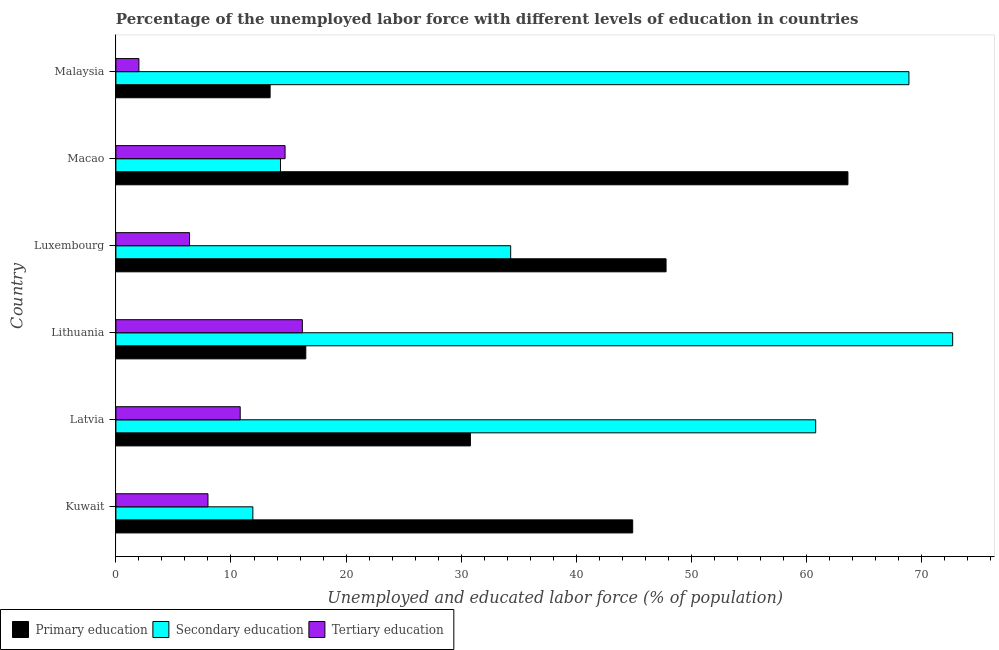How many different coloured bars are there?
Offer a terse response. 3. How many groups of bars are there?
Keep it short and to the point. 6. Are the number of bars per tick equal to the number of legend labels?
Ensure brevity in your answer.  Yes. How many bars are there on the 1st tick from the top?
Provide a succinct answer. 3. How many bars are there on the 4th tick from the bottom?
Your response must be concise. 3. What is the label of the 5th group of bars from the top?
Offer a very short reply. Latvia. What is the percentage of labor force who received primary education in Luxembourg?
Keep it short and to the point. 47.8. Across all countries, what is the maximum percentage of labor force who received primary education?
Your response must be concise. 63.6. Across all countries, what is the minimum percentage of labor force who received tertiary education?
Provide a short and direct response. 2. In which country was the percentage of labor force who received tertiary education maximum?
Keep it short and to the point. Lithuania. In which country was the percentage of labor force who received primary education minimum?
Offer a terse response. Malaysia. What is the total percentage of labor force who received tertiary education in the graph?
Provide a short and direct response. 58.1. What is the difference between the percentage of labor force who received tertiary education in Luxembourg and the percentage of labor force who received secondary education in Kuwait?
Provide a succinct answer. -5.5. What is the average percentage of labor force who received primary education per country?
Provide a succinct answer. 36.17. What is the difference between the percentage of labor force who received secondary education and percentage of labor force who received tertiary education in Malaysia?
Ensure brevity in your answer.  66.9. What is the ratio of the percentage of labor force who received primary education in Luxembourg to that in Malaysia?
Keep it short and to the point. 3.57. What is the difference between the highest and the second highest percentage of labor force who received tertiary education?
Offer a very short reply. 1.5. What is the difference between the highest and the lowest percentage of labor force who received secondary education?
Offer a very short reply. 60.8. In how many countries, is the percentage of labor force who received secondary education greater than the average percentage of labor force who received secondary education taken over all countries?
Provide a short and direct response. 3. What does the 1st bar from the top in Kuwait represents?
Provide a short and direct response. Tertiary education. What does the 2nd bar from the bottom in Macao represents?
Keep it short and to the point. Secondary education. Is it the case that in every country, the sum of the percentage of labor force who received primary education and percentage of labor force who received secondary education is greater than the percentage of labor force who received tertiary education?
Keep it short and to the point. Yes. How many bars are there?
Provide a short and direct response. 18. Are the values on the major ticks of X-axis written in scientific E-notation?
Your answer should be very brief. No. Does the graph contain any zero values?
Offer a terse response. No. Does the graph contain grids?
Keep it short and to the point. No. What is the title of the graph?
Your answer should be compact. Percentage of the unemployed labor force with different levels of education in countries. What is the label or title of the X-axis?
Offer a very short reply. Unemployed and educated labor force (% of population). What is the label or title of the Y-axis?
Offer a very short reply. Country. What is the Unemployed and educated labor force (% of population) in Primary education in Kuwait?
Your response must be concise. 44.9. What is the Unemployed and educated labor force (% of population) in Secondary education in Kuwait?
Provide a succinct answer. 11.9. What is the Unemployed and educated labor force (% of population) of Tertiary education in Kuwait?
Provide a short and direct response. 8. What is the Unemployed and educated labor force (% of population) in Primary education in Latvia?
Offer a terse response. 30.8. What is the Unemployed and educated labor force (% of population) of Secondary education in Latvia?
Offer a terse response. 60.8. What is the Unemployed and educated labor force (% of population) of Tertiary education in Latvia?
Give a very brief answer. 10.8. What is the Unemployed and educated labor force (% of population) of Primary education in Lithuania?
Keep it short and to the point. 16.5. What is the Unemployed and educated labor force (% of population) of Secondary education in Lithuania?
Make the answer very short. 72.7. What is the Unemployed and educated labor force (% of population) of Tertiary education in Lithuania?
Your answer should be very brief. 16.2. What is the Unemployed and educated labor force (% of population) in Primary education in Luxembourg?
Provide a succinct answer. 47.8. What is the Unemployed and educated labor force (% of population) in Secondary education in Luxembourg?
Provide a short and direct response. 34.3. What is the Unemployed and educated labor force (% of population) in Tertiary education in Luxembourg?
Your response must be concise. 6.4. What is the Unemployed and educated labor force (% of population) of Primary education in Macao?
Make the answer very short. 63.6. What is the Unemployed and educated labor force (% of population) in Secondary education in Macao?
Provide a short and direct response. 14.3. What is the Unemployed and educated labor force (% of population) of Tertiary education in Macao?
Ensure brevity in your answer.  14.7. What is the Unemployed and educated labor force (% of population) in Primary education in Malaysia?
Offer a very short reply. 13.4. What is the Unemployed and educated labor force (% of population) of Secondary education in Malaysia?
Offer a terse response. 68.9. What is the Unemployed and educated labor force (% of population) in Tertiary education in Malaysia?
Give a very brief answer. 2. Across all countries, what is the maximum Unemployed and educated labor force (% of population) of Primary education?
Keep it short and to the point. 63.6. Across all countries, what is the maximum Unemployed and educated labor force (% of population) in Secondary education?
Make the answer very short. 72.7. Across all countries, what is the maximum Unemployed and educated labor force (% of population) in Tertiary education?
Ensure brevity in your answer.  16.2. Across all countries, what is the minimum Unemployed and educated labor force (% of population) in Primary education?
Offer a terse response. 13.4. Across all countries, what is the minimum Unemployed and educated labor force (% of population) in Secondary education?
Provide a short and direct response. 11.9. Across all countries, what is the minimum Unemployed and educated labor force (% of population) in Tertiary education?
Your response must be concise. 2. What is the total Unemployed and educated labor force (% of population) in Primary education in the graph?
Your answer should be very brief. 217. What is the total Unemployed and educated labor force (% of population) of Secondary education in the graph?
Give a very brief answer. 262.9. What is the total Unemployed and educated labor force (% of population) in Tertiary education in the graph?
Your answer should be very brief. 58.1. What is the difference between the Unemployed and educated labor force (% of population) in Secondary education in Kuwait and that in Latvia?
Make the answer very short. -48.9. What is the difference between the Unemployed and educated labor force (% of population) of Primary education in Kuwait and that in Lithuania?
Give a very brief answer. 28.4. What is the difference between the Unemployed and educated labor force (% of population) of Secondary education in Kuwait and that in Lithuania?
Provide a succinct answer. -60.8. What is the difference between the Unemployed and educated labor force (% of population) in Primary education in Kuwait and that in Luxembourg?
Ensure brevity in your answer.  -2.9. What is the difference between the Unemployed and educated labor force (% of population) in Secondary education in Kuwait and that in Luxembourg?
Keep it short and to the point. -22.4. What is the difference between the Unemployed and educated labor force (% of population) of Tertiary education in Kuwait and that in Luxembourg?
Ensure brevity in your answer.  1.6. What is the difference between the Unemployed and educated labor force (% of population) in Primary education in Kuwait and that in Macao?
Your response must be concise. -18.7. What is the difference between the Unemployed and educated labor force (% of population) in Secondary education in Kuwait and that in Macao?
Offer a terse response. -2.4. What is the difference between the Unemployed and educated labor force (% of population) in Primary education in Kuwait and that in Malaysia?
Offer a very short reply. 31.5. What is the difference between the Unemployed and educated labor force (% of population) in Secondary education in Kuwait and that in Malaysia?
Keep it short and to the point. -57. What is the difference between the Unemployed and educated labor force (% of population) of Primary education in Latvia and that in Lithuania?
Ensure brevity in your answer.  14.3. What is the difference between the Unemployed and educated labor force (% of population) of Secondary education in Latvia and that in Lithuania?
Give a very brief answer. -11.9. What is the difference between the Unemployed and educated labor force (% of population) of Primary education in Latvia and that in Luxembourg?
Provide a succinct answer. -17. What is the difference between the Unemployed and educated labor force (% of population) in Secondary education in Latvia and that in Luxembourg?
Offer a very short reply. 26.5. What is the difference between the Unemployed and educated labor force (% of population) of Tertiary education in Latvia and that in Luxembourg?
Offer a very short reply. 4.4. What is the difference between the Unemployed and educated labor force (% of population) in Primary education in Latvia and that in Macao?
Offer a very short reply. -32.8. What is the difference between the Unemployed and educated labor force (% of population) in Secondary education in Latvia and that in Macao?
Give a very brief answer. 46.5. What is the difference between the Unemployed and educated labor force (% of population) of Tertiary education in Latvia and that in Macao?
Your response must be concise. -3.9. What is the difference between the Unemployed and educated labor force (% of population) in Primary education in Latvia and that in Malaysia?
Make the answer very short. 17.4. What is the difference between the Unemployed and educated labor force (% of population) of Primary education in Lithuania and that in Luxembourg?
Make the answer very short. -31.3. What is the difference between the Unemployed and educated labor force (% of population) of Secondary education in Lithuania and that in Luxembourg?
Provide a short and direct response. 38.4. What is the difference between the Unemployed and educated labor force (% of population) in Tertiary education in Lithuania and that in Luxembourg?
Offer a very short reply. 9.8. What is the difference between the Unemployed and educated labor force (% of population) of Primary education in Lithuania and that in Macao?
Offer a terse response. -47.1. What is the difference between the Unemployed and educated labor force (% of population) of Secondary education in Lithuania and that in Macao?
Provide a short and direct response. 58.4. What is the difference between the Unemployed and educated labor force (% of population) in Tertiary education in Lithuania and that in Macao?
Offer a terse response. 1.5. What is the difference between the Unemployed and educated labor force (% of population) of Primary education in Luxembourg and that in Macao?
Your answer should be compact. -15.8. What is the difference between the Unemployed and educated labor force (% of population) in Secondary education in Luxembourg and that in Macao?
Your answer should be very brief. 20. What is the difference between the Unemployed and educated labor force (% of population) of Primary education in Luxembourg and that in Malaysia?
Provide a succinct answer. 34.4. What is the difference between the Unemployed and educated labor force (% of population) of Secondary education in Luxembourg and that in Malaysia?
Provide a short and direct response. -34.6. What is the difference between the Unemployed and educated labor force (% of population) of Primary education in Macao and that in Malaysia?
Give a very brief answer. 50.2. What is the difference between the Unemployed and educated labor force (% of population) in Secondary education in Macao and that in Malaysia?
Your response must be concise. -54.6. What is the difference between the Unemployed and educated labor force (% of population) in Primary education in Kuwait and the Unemployed and educated labor force (% of population) in Secondary education in Latvia?
Your answer should be very brief. -15.9. What is the difference between the Unemployed and educated labor force (% of population) of Primary education in Kuwait and the Unemployed and educated labor force (% of population) of Tertiary education in Latvia?
Your response must be concise. 34.1. What is the difference between the Unemployed and educated labor force (% of population) of Secondary education in Kuwait and the Unemployed and educated labor force (% of population) of Tertiary education in Latvia?
Provide a succinct answer. 1.1. What is the difference between the Unemployed and educated labor force (% of population) in Primary education in Kuwait and the Unemployed and educated labor force (% of population) in Secondary education in Lithuania?
Your answer should be very brief. -27.8. What is the difference between the Unemployed and educated labor force (% of population) in Primary education in Kuwait and the Unemployed and educated labor force (% of population) in Tertiary education in Lithuania?
Offer a very short reply. 28.7. What is the difference between the Unemployed and educated labor force (% of population) of Primary education in Kuwait and the Unemployed and educated labor force (% of population) of Secondary education in Luxembourg?
Give a very brief answer. 10.6. What is the difference between the Unemployed and educated labor force (% of population) of Primary education in Kuwait and the Unemployed and educated labor force (% of population) of Tertiary education in Luxembourg?
Ensure brevity in your answer.  38.5. What is the difference between the Unemployed and educated labor force (% of population) of Secondary education in Kuwait and the Unemployed and educated labor force (% of population) of Tertiary education in Luxembourg?
Your answer should be very brief. 5.5. What is the difference between the Unemployed and educated labor force (% of population) of Primary education in Kuwait and the Unemployed and educated labor force (% of population) of Secondary education in Macao?
Offer a very short reply. 30.6. What is the difference between the Unemployed and educated labor force (% of population) in Primary education in Kuwait and the Unemployed and educated labor force (% of population) in Tertiary education in Macao?
Your answer should be compact. 30.2. What is the difference between the Unemployed and educated labor force (% of population) of Primary education in Kuwait and the Unemployed and educated labor force (% of population) of Secondary education in Malaysia?
Your answer should be compact. -24. What is the difference between the Unemployed and educated labor force (% of population) in Primary education in Kuwait and the Unemployed and educated labor force (% of population) in Tertiary education in Malaysia?
Your response must be concise. 42.9. What is the difference between the Unemployed and educated labor force (% of population) in Secondary education in Kuwait and the Unemployed and educated labor force (% of population) in Tertiary education in Malaysia?
Provide a short and direct response. 9.9. What is the difference between the Unemployed and educated labor force (% of population) in Primary education in Latvia and the Unemployed and educated labor force (% of population) in Secondary education in Lithuania?
Provide a succinct answer. -41.9. What is the difference between the Unemployed and educated labor force (% of population) of Primary education in Latvia and the Unemployed and educated labor force (% of population) of Tertiary education in Lithuania?
Make the answer very short. 14.6. What is the difference between the Unemployed and educated labor force (% of population) of Secondary education in Latvia and the Unemployed and educated labor force (% of population) of Tertiary education in Lithuania?
Offer a very short reply. 44.6. What is the difference between the Unemployed and educated labor force (% of population) in Primary education in Latvia and the Unemployed and educated labor force (% of population) in Tertiary education in Luxembourg?
Ensure brevity in your answer.  24.4. What is the difference between the Unemployed and educated labor force (% of population) of Secondary education in Latvia and the Unemployed and educated labor force (% of population) of Tertiary education in Luxembourg?
Offer a very short reply. 54.4. What is the difference between the Unemployed and educated labor force (% of population) in Primary education in Latvia and the Unemployed and educated labor force (% of population) in Secondary education in Macao?
Ensure brevity in your answer.  16.5. What is the difference between the Unemployed and educated labor force (% of population) of Primary education in Latvia and the Unemployed and educated labor force (% of population) of Tertiary education in Macao?
Provide a succinct answer. 16.1. What is the difference between the Unemployed and educated labor force (% of population) in Secondary education in Latvia and the Unemployed and educated labor force (% of population) in Tertiary education in Macao?
Offer a terse response. 46.1. What is the difference between the Unemployed and educated labor force (% of population) in Primary education in Latvia and the Unemployed and educated labor force (% of population) in Secondary education in Malaysia?
Give a very brief answer. -38.1. What is the difference between the Unemployed and educated labor force (% of population) of Primary education in Latvia and the Unemployed and educated labor force (% of population) of Tertiary education in Malaysia?
Your answer should be compact. 28.8. What is the difference between the Unemployed and educated labor force (% of population) of Secondary education in Latvia and the Unemployed and educated labor force (% of population) of Tertiary education in Malaysia?
Give a very brief answer. 58.8. What is the difference between the Unemployed and educated labor force (% of population) in Primary education in Lithuania and the Unemployed and educated labor force (% of population) in Secondary education in Luxembourg?
Give a very brief answer. -17.8. What is the difference between the Unemployed and educated labor force (% of population) of Primary education in Lithuania and the Unemployed and educated labor force (% of population) of Tertiary education in Luxembourg?
Keep it short and to the point. 10.1. What is the difference between the Unemployed and educated labor force (% of population) of Secondary education in Lithuania and the Unemployed and educated labor force (% of population) of Tertiary education in Luxembourg?
Your answer should be compact. 66.3. What is the difference between the Unemployed and educated labor force (% of population) in Primary education in Lithuania and the Unemployed and educated labor force (% of population) in Secondary education in Malaysia?
Your answer should be compact. -52.4. What is the difference between the Unemployed and educated labor force (% of population) in Secondary education in Lithuania and the Unemployed and educated labor force (% of population) in Tertiary education in Malaysia?
Provide a succinct answer. 70.7. What is the difference between the Unemployed and educated labor force (% of population) in Primary education in Luxembourg and the Unemployed and educated labor force (% of population) in Secondary education in Macao?
Keep it short and to the point. 33.5. What is the difference between the Unemployed and educated labor force (% of population) in Primary education in Luxembourg and the Unemployed and educated labor force (% of population) in Tertiary education in Macao?
Your response must be concise. 33.1. What is the difference between the Unemployed and educated labor force (% of population) of Secondary education in Luxembourg and the Unemployed and educated labor force (% of population) of Tertiary education in Macao?
Offer a terse response. 19.6. What is the difference between the Unemployed and educated labor force (% of population) of Primary education in Luxembourg and the Unemployed and educated labor force (% of population) of Secondary education in Malaysia?
Provide a succinct answer. -21.1. What is the difference between the Unemployed and educated labor force (% of population) of Primary education in Luxembourg and the Unemployed and educated labor force (% of population) of Tertiary education in Malaysia?
Provide a succinct answer. 45.8. What is the difference between the Unemployed and educated labor force (% of population) in Secondary education in Luxembourg and the Unemployed and educated labor force (% of population) in Tertiary education in Malaysia?
Ensure brevity in your answer.  32.3. What is the difference between the Unemployed and educated labor force (% of population) in Primary education in Macao and the Unemployed and educated labor force (% of population) in Tertiary education in Malaysia?
Offer a terse response. 61.6. What is the average Unemployed and educated labor force (% of population) of Primary education per country?
Provide a succinct answer. 36.17. What is the average Unemployed and educated labor force (% of population) of Secondary education per country?
Provide a short and direct response. 43.82. What is the average Unemployed and educated labor force (% of population) in Tertiary education per country?
Offer a terse response. 9.68. What is the difference between the Unemployed and educated labor force (% of population) of Primary education and Unemployed and educated labor force (% of population) of Tertiary education in Kuwait?
Provide a short and direct response. 36.9. What is the difference between the Unemployed and educated labor force (% of population) of Primary education and Unemployed and educated labor force (% of population) of Secondary education in Lithuania?
Your answer should be compact. -56.2. What is the difference between the Unemployed and educated labor force (% of population) of Primary education and Unemployed and educated labor force (% of population) of Tertiary education in Lithuania?
Your answer should be very brief. 0.3. What is the difference between the Unemployed and educated labor force (% of population) in Secondary education and Unemployed and educated labor force (% of population) in Tertiary education in Lithuania?
Provide a succinct answer. 56.5. What is the difference between the Unemployed and educated labor force (% of population) of Primary education and Unemployed and educated labor force (% of population) of Tertiary education in Luxembourg?
Offer a very short reply. 41.4. What is the difference between the Unemployed and educated labor force (% of population) of Secondary education and Unemployed and educated labor force (% of population) of Tertiary education in Luxembourg?
Make the answer very short. 27.9. What is the difference between the Unemployed and educated labor force (% of population) in Primary education and Unemployed and educated labor force (% of population) in Secondary education in Macao?
Your answer should be compact. 49.3. What is the difference between the Unemployed and educated labor force (% of population) of Primary education and Unemployed and educated labor force (% of population) of Tertiary education in Macao?
Keep it short and to the point. 48.9. What is the difference between the Unemployed and educated labor force (% of population) in Secondary education and Unemployed and educated labor force (% of population) in Tertiary education in Macao?
Provide a succinct answer. -0.4. What is the difference between the Unemployed and educated labor force (% of population) in Primary education and Unemployed and educated labor force (% of population) in Secondary education in Malaysia?
Offer a very short reply. -55.5. What is the difference between the Unemployed and educated labor force (% of population) of Primary education and Unemployed and educated labor force (% of population) of Tertiary education in Malaysia?
Your response must be concise. 11.4. What is the difference between the Unemployed and educated labor force (% of population) in Secondary education and Unemployed and educated labor force (% of population) in Tertiary education in Malaysia?
Provide a succinct answer. 66.9. What is the ratio of the Unemployed and educated labor force (% of population) in Primary education in Kuwait to that in Latvia?
Your answer should be very brief. 1.46. What is the ratio of the Unemployed and educated labor force (% of population) of Secondary education in Kuwait to that in Latvia?
Give a very brief answer. 0.2. What is the ratio of the Unemployed and educated labor force (% of population) in Tertiary education in Kuwait to that in Latvia?
Make the answer very short. 0.74. What is the ratio of the Unemployed and educated labor force (% of population) of Primary education in Kuwait to that in Lithuania?
Give a very brief answer. 2.72. What is the ratio of the Unemployed and educated labor force (% of population) in Secondary education in Kuwait to that in Lithuania?
Your answer should be compact. 0.16. What is the ratio of the Unemployed and educated labor force (% of population) in Tertiary education in Kuwait to that in Lithuania?
Make the answer very short. 0.49. What is the ratio of the Unemployed and educated labor force (% of population) of Primary education in Kuwait to that in Luxembourg?
Provide a succinct answer. 0.94. What is the ratio of the Unemployed and educated labor force (% of population) of Secondary education in Kuwait to that in Luxembourg?
Your answer should be compact. 0.35. What is the ratio of the Unemployed and educated labor force (% of population) of Primary education in Kuwait to that in Macao?
Your answer should be very brief. 0.71. What is the ratio of the Unemployed and educated labor force (% of population) of Secondary education in Kuwait to that in Macao?
Ensure brevity in your answer.  0.83. What is the ratio of the Unemployed and educated labor force (% of population) of Tertiary education in Kuwait to that in Macao?
Keep it short and to the point. 0.54. What is the ratio of the Unemployed and educated labor force (% of population) in Primary education in Kuwait to that in Malaysia?
Keep it short and to the point. 3.35. What is the ratio of the Unemployed and educated labor force (% of population) of Secondary education in Kuwait to that in Malaysia?
Your answer should be very brief. 0.17. What is the ratio of the Unemployed and educated labor force (% of population) of Tertiary education in Kuwait to that in Malaysia?
Your answer should be compact. 4. What is the ratio of the Unemployed and educated labor force (% of population) of Primary education in Latvia to that in Lithuania?
Your response must be concise. 1.87. What is the ratio of the Unemployed and educated labor force (% of population) in Secondary education in Latvia to that in Lithuania?
Keep it short and to the point. 0.84. What is the ratio of the Unemployed and educated labor force (% of population) of Primary education in Latvia to that in Luxembourg?
Provide a short and direct response. 0.64. What is the ratio of the Unemployed and educated labor force (% of population) of Secondary education in Latvia to that in Luxembourg?
Give a very brief answer. 1.77. What is the ratio of the Unemployed and educated labor force (% of population) of Tertiary education in Latvia to that in Luxembourg?
Make the answer very short. 1.69. What is the ratio of the Unemployed and educated labor force (% of population) of Primary education in Latvia to that in Macao?
Your answer should be compact. 0.48. What is the ratio of the Unemployed and educated labor force (% of population) of Secondary education in Latvia to that in Macao?
Your response must be concise. 4.25. What is the ratio of the Unemployed and educated labor force (% of population) in Tertiary education in Latvia to that in Macao?
Offer a terse response. 0.73. What is the ratio of the Unemployed and educated labor force (% of population) of Primary education in Latvia to that in Malaysia?
Your response must be concise. 2.3. What is the ratio of the Unemployed and educated labor force (% of population) in Secondary education in Latvia to that in Malaysia?
Provide a short and direct response. 0.88. What is the ratio of the Unemployed and educated labor force (% of population) of Primary education in Lithuania to that in Luxembourg?
Provide a short and direct response. 0.35. What is the ratio of the Unemployed and educated labor force (% of population) of Secondary education in Lithuania to that in Luxembourg?
Offer a very short reply. 2.12. What is the ratio of the Unemployed and educated labor force (% of population) of Tertiary education in Lithuania to that in Luxembourg?
Your answer should be compact. 2.53. What is the ratio of the Unemployed and educated labor force (% of population) of Primary education in Lithuania to that in Macao?
Offer a very short reply. 0.26. What is the ratio of the Unemployed and educated labor force (% of population) in Secondary education in Lithuania to that in Macao?
Your answer should be compact. 5.08. What is the ratio of the Unemployed and educated labor force (% of population) in Tertiary education in Lithuania to that in Macao?
Give a very brief answer. 1.1. What is the ratio of the Unemployed and educated labor force (% of population) of Primary education in Lithuania to that in Malaysia?
Your answer should be very brief. 1.23. What is the ratio of the Unemployed and educated labor force (% of population) in Secondary education in Lithuania to that in Malaysia?
Your response must be concise. 1.06. What is the ratio of the Unemployed and educated labor force (% of population) in Tertiary education in Lithuania to that in Malaysia?
Offer a terse response. 8.1. What is the ratio of the Unemployed and educated labor force (% of population) in Primary education in Luxembourg to that in Macao?
Provide a succinct answer. 0.75. What is the ratio of the Unemployed and educated labor force (% of population) of Secondary education in Luxembourg to that in Macao?
Offer a very short reply. 2.4. What is the ratio of the Unemployed and educated labor force (% of population) in Tertiary education in Luxembourg to that in Macao?
Offer a very short reply. 0.44. What is the ratio of the Unemployed and educated labor force (% of population) in Primary education in Luxembourg to that in Malaysia?
Offer a very short reply. 3.57. What is the ratio of the Unemployed and educated labor force (% of population) in Secondary education in Luxembourg to that in Malaysia?
Provide a succinct answer. 0.5. What is the ratio of the Unemployed and educated labor force (% of population) of Primary education in Macao to that in Malaysia?
Make the answer very short. 4.75. What is the ratio of the Unemployed and educated labor force (% of population) of Secondary education in Macao to that in Malaysia?
Your response must be concise. 0.21. What is the ratio of the Unemployed and educated labor force (% of population) of Tertiary education in Macao to that in Malaysia?
Provide a succinct answer. 7.35. What is the difference between the highest and the second highest Unemployed and educated labor force (% of population) in Primary education?
Keep it short and to the point. 15.8. What is the difference between the highest and the second highest Unemployed and educated labor force (% of population) of Secondary education?
Keep it short and to the point. 3.8. What is the difference between the highest and the lowest Unemployed and educated labor force (% of population) of Primary education?
Ensure brevity in your answer.  50.2. What is the difference between the highest and the lowest Unemployed and educated labor force (% of population) in Secondary education?
Give a very brief answer. 60.8. 